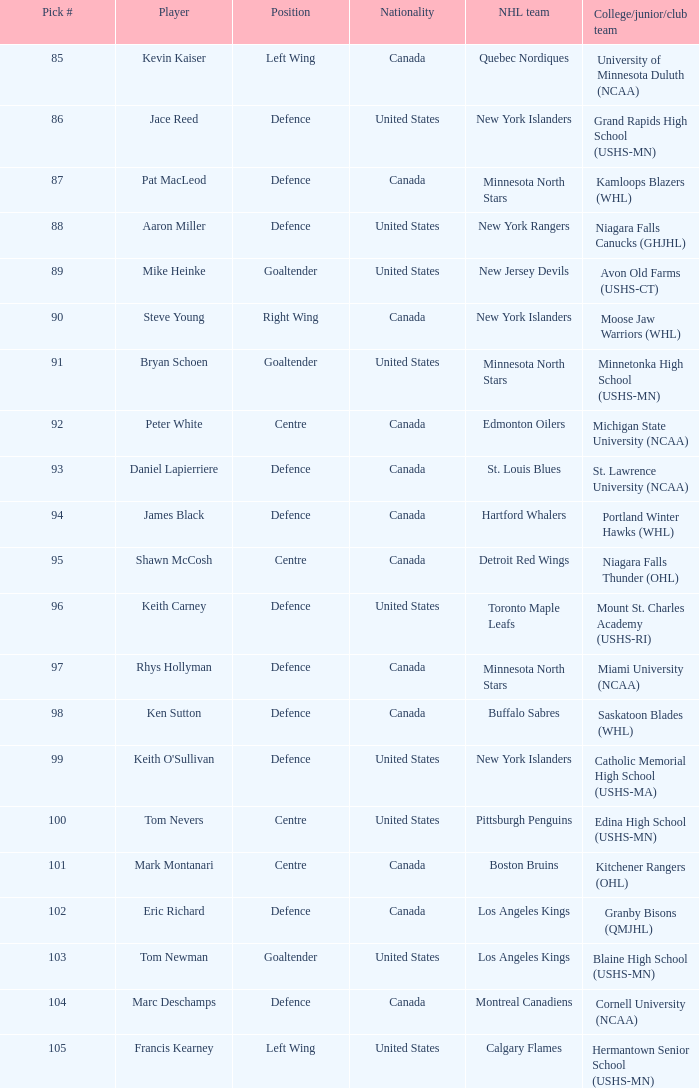What draft position was marc deschamps? 104.0. 